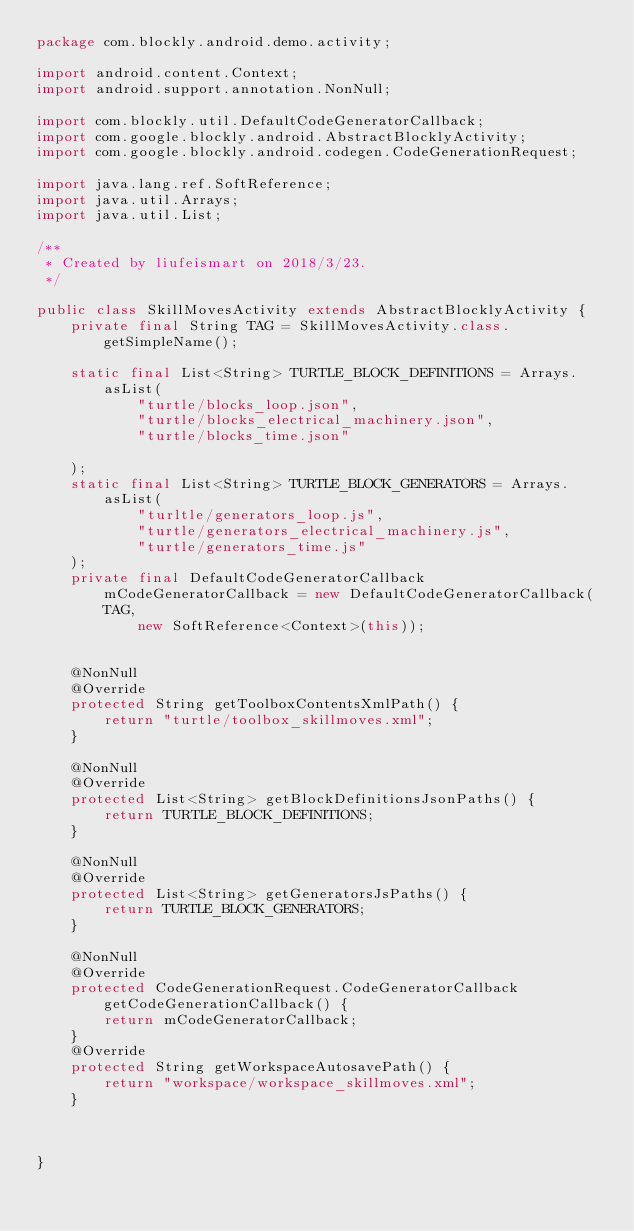Convert code to text. <code><loc_0><loc_0><loc_500><loc_500><_Java_>package com.blockly.android.demo.activity;

import android.content.Context;
import android.support.annotation.NonNull;

import com.blockly.util.DefaultCodeGeneratorCallback;
import com.google.blockly.android.AbstractBlocklyActivity;
import com.google.blockly.android.codegen.CodeGenerationRequest;

import java.lang.ref.SoftReference;
import java.util.Arrays;
import java.util.List;

/**
 * Created by liufeismart on 2018/3/23.
 */

public class SkillMovesActivity extends AbstractBlocklyActivity {
    private final String TAG = SkillMovesActivity.class.getSimpleName();

    static final List<String> TURTLE_BLOCK_DEFINITIONS = Arrays.asList(
            "turtle/blocks_loop.json",
            "turtle/blocks_electrical_machinery.json",
            "turtle/blocks_time.json"

    );
    static final List<String> TURTLE_BLOCK_GENERATORS = Arrays.asList(
            "turltle/generators_loop.js",
            "turtle/generators_electrical_machinery.js",
            "turtle/generators_time.js"
    );
    private final DefaultCodeGeneratorCallback mCodeGeneratorCallback = new DefaultCodeGeneratorCallback(TAG,
            new SoftReference<Context>(this));


    @NonNull
    @Override
    protected String getToolboxContentsXmlPath() {
        return "turtle/toolbox_skillmoves.xml";
    }

    @NonNull
    @Override
    protected List<String> getBlockDefinitionsJsonPaths() {
        return TURTLE_BLOCK_DEFINITIONS;
    }

    @NonNull
    @Override
    protected List<String> getGeneratorsJsPaths() {
        return TURTLE_BLOCK_GENERATORS;
    }

    @NonNull
    @Override
    protected CodeGenerationRequest.CodeGeneratorCallback getCodeGenerationCallback() {
        return mCodeGeneratorCallback;
    }
    @Override
    protected String getWorkspaceAutosavePath() {
        return "workspace/workspace_skillmoves.xml";
    }



}


</code> 